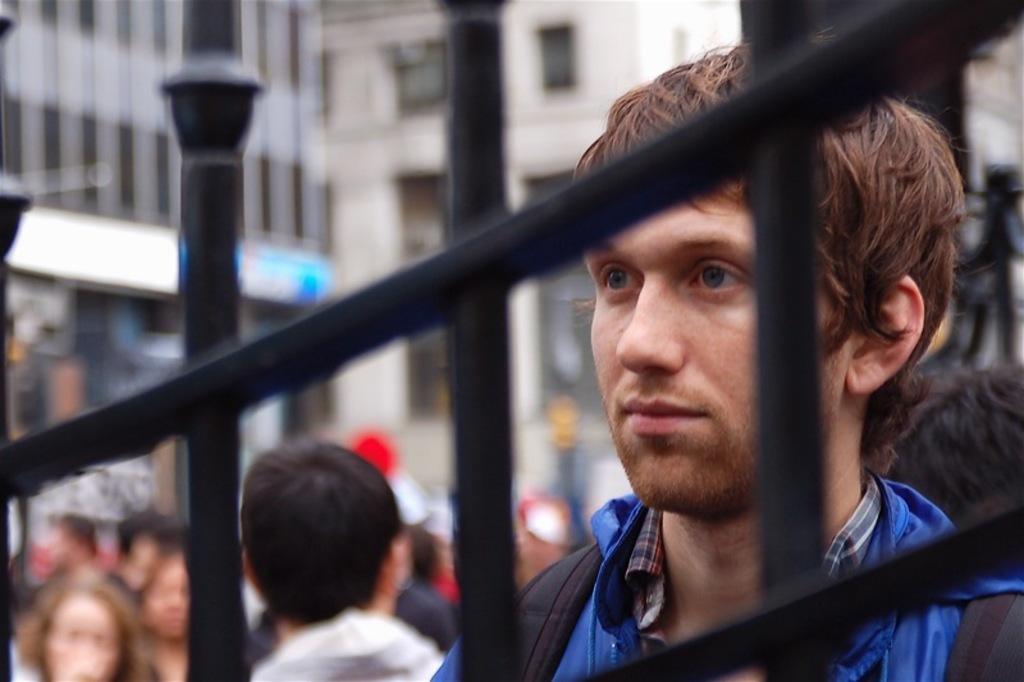Please provide a concise description of this image. In the background we can see the buildings and its blur. In this picture we can see the people. We can see black grills and we can see a man wearing a blue jacket. 